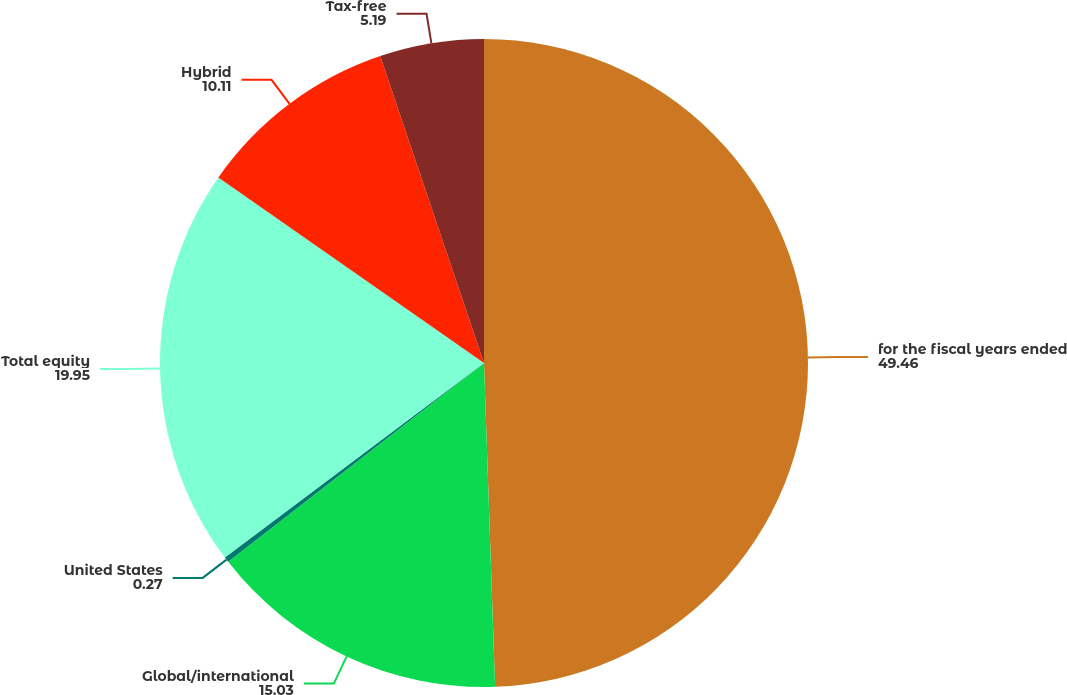Convert chart. <chart><loc_0><loc_0><loc_500><loc_500><pie_chart><fcel>for the fiscal years ended<fcel>Global/international<fcel>United States<fcel>Total equity<fcel>Hybrid<fcel>Tax-free<nl><fcel>49.46%<fcel>15.03%<fcel>0.27%<fcel>19.95%<fcel>10.11%<fcel>5.19%<nl></chart> 